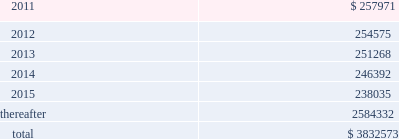American tower corporation and subsidiaries notes to consolidated financial statements mexico litigation 2014one of the company 2019s subsidiaries , spectrasite communications , inc .
( 201csci 201d ) , is involved in a lawsuit brought in mexico against a former mexican subsidiary of sci ( the subsidiary of sci was sold in 2002 , prior to the company 2019s merger with sci 2019s parent in 2005 ) .
The lawsuit concerns a terminated tower construction contract and related agreements with a wireless carrier in mexico .
The primary issue for the company is whether sci itself can be found liable to the mexican carrier .
The trial and lower appellate courts initially found that sci had no such liability in part because mexican courts do not have the necessary jurisdiction over sci .
Following several decisions by mexican appellate courts , including the supreme court of mexico , and related appeals by both parties , an intermediate appellate court issued a new decision that would , if enforceable , reimpose liability on sci in september 2010 .
In its decision , the intermediate appellate court identified potential damages of approximately $ 6.7 million , and on october 14 , 2010 , the company filed a new constitutional appeal to again dispute the decision .
As a result , at this stage of the proceeding , the company is unable to determine whether the liability imposed on sci by the september 2010 decision will survive or to estimate its share , if any , of that potential liability if the decision survives the pending appeal .
Xcel litigation 2014on june 3 , 2010 , horse-shoe capital ( 201chorse-shoe 201d ) , a company formed under the laws of the republic of mauritius , filed a complaint in the supreme court of the state of new york , new york county , with respect to horse-shoe 2019s sale of xcel to american tower mauritius ( 201catmauritius 201d ) , the company 2019s wholly-owned subsidiary formed under the laws of the republic of mauritius .
The complaint names atmauritius , ati and the company as defendants , and the dispute concerns the timing and amount of distributions to be made by atmauritius to horse-shoe from a $ 7.5 million holdback escrow account and a $ 15.7 million tax escrow account , each established by the transaction agreements at closing .
The complaint seeks release of the entire holdback escrow account , plus an additional $ 2.8 million , as well as the release of approximately $ 12.0 million of the tax escrow account .
The complaint also seeks punitive damages in excess of $ 69.0 million .
The company filed an answer to the complaint in august 2010 , disputing both the amounts alleged to be owed under the escrow agreements as well as the timing of the escrow distributions .
The company also asserted in its answer that the demand for punitive damages is meritless .
The parties have filed cross-motions for summary judgment concerning the release of the tax escrow account and in january 2011 the court granted the company 2019s motion for summary judgment , finding no obligation for the company to release the disputed portion of the tax escrow until 2013 .
Other claims are pending .
The company is vigorously defending the lawsuit .
Lease obligations 2014the company leases certain land , office and tower space under operating leases that expire over various terms .
Many of the leases contain renewal options with specified increases in lease payments upon exercise of the renewal option .
Escalation clauses present in operating leases , excluding those tied to cpi or other inflation-based indices , are recognized on a straight-line basis over the non-cancellable term of the lease .
Future minimum rental payments under non-cancellable operating leases include payments for certain renewal periods at the company 2019s option because failure to renew could result in a loss of the applicable tower site and related revenues from tenant leases , thereby making it reasonably assured that the company will renew the lease .
Such payments in effect at december 31 , 2010 are as follows ( in thousands ) : year ending december 31 .

What portion of the total future minimum rental payments is due in the next 12 months? 
Computations: (257971 / 3832573)
Answer: 0.06731. 